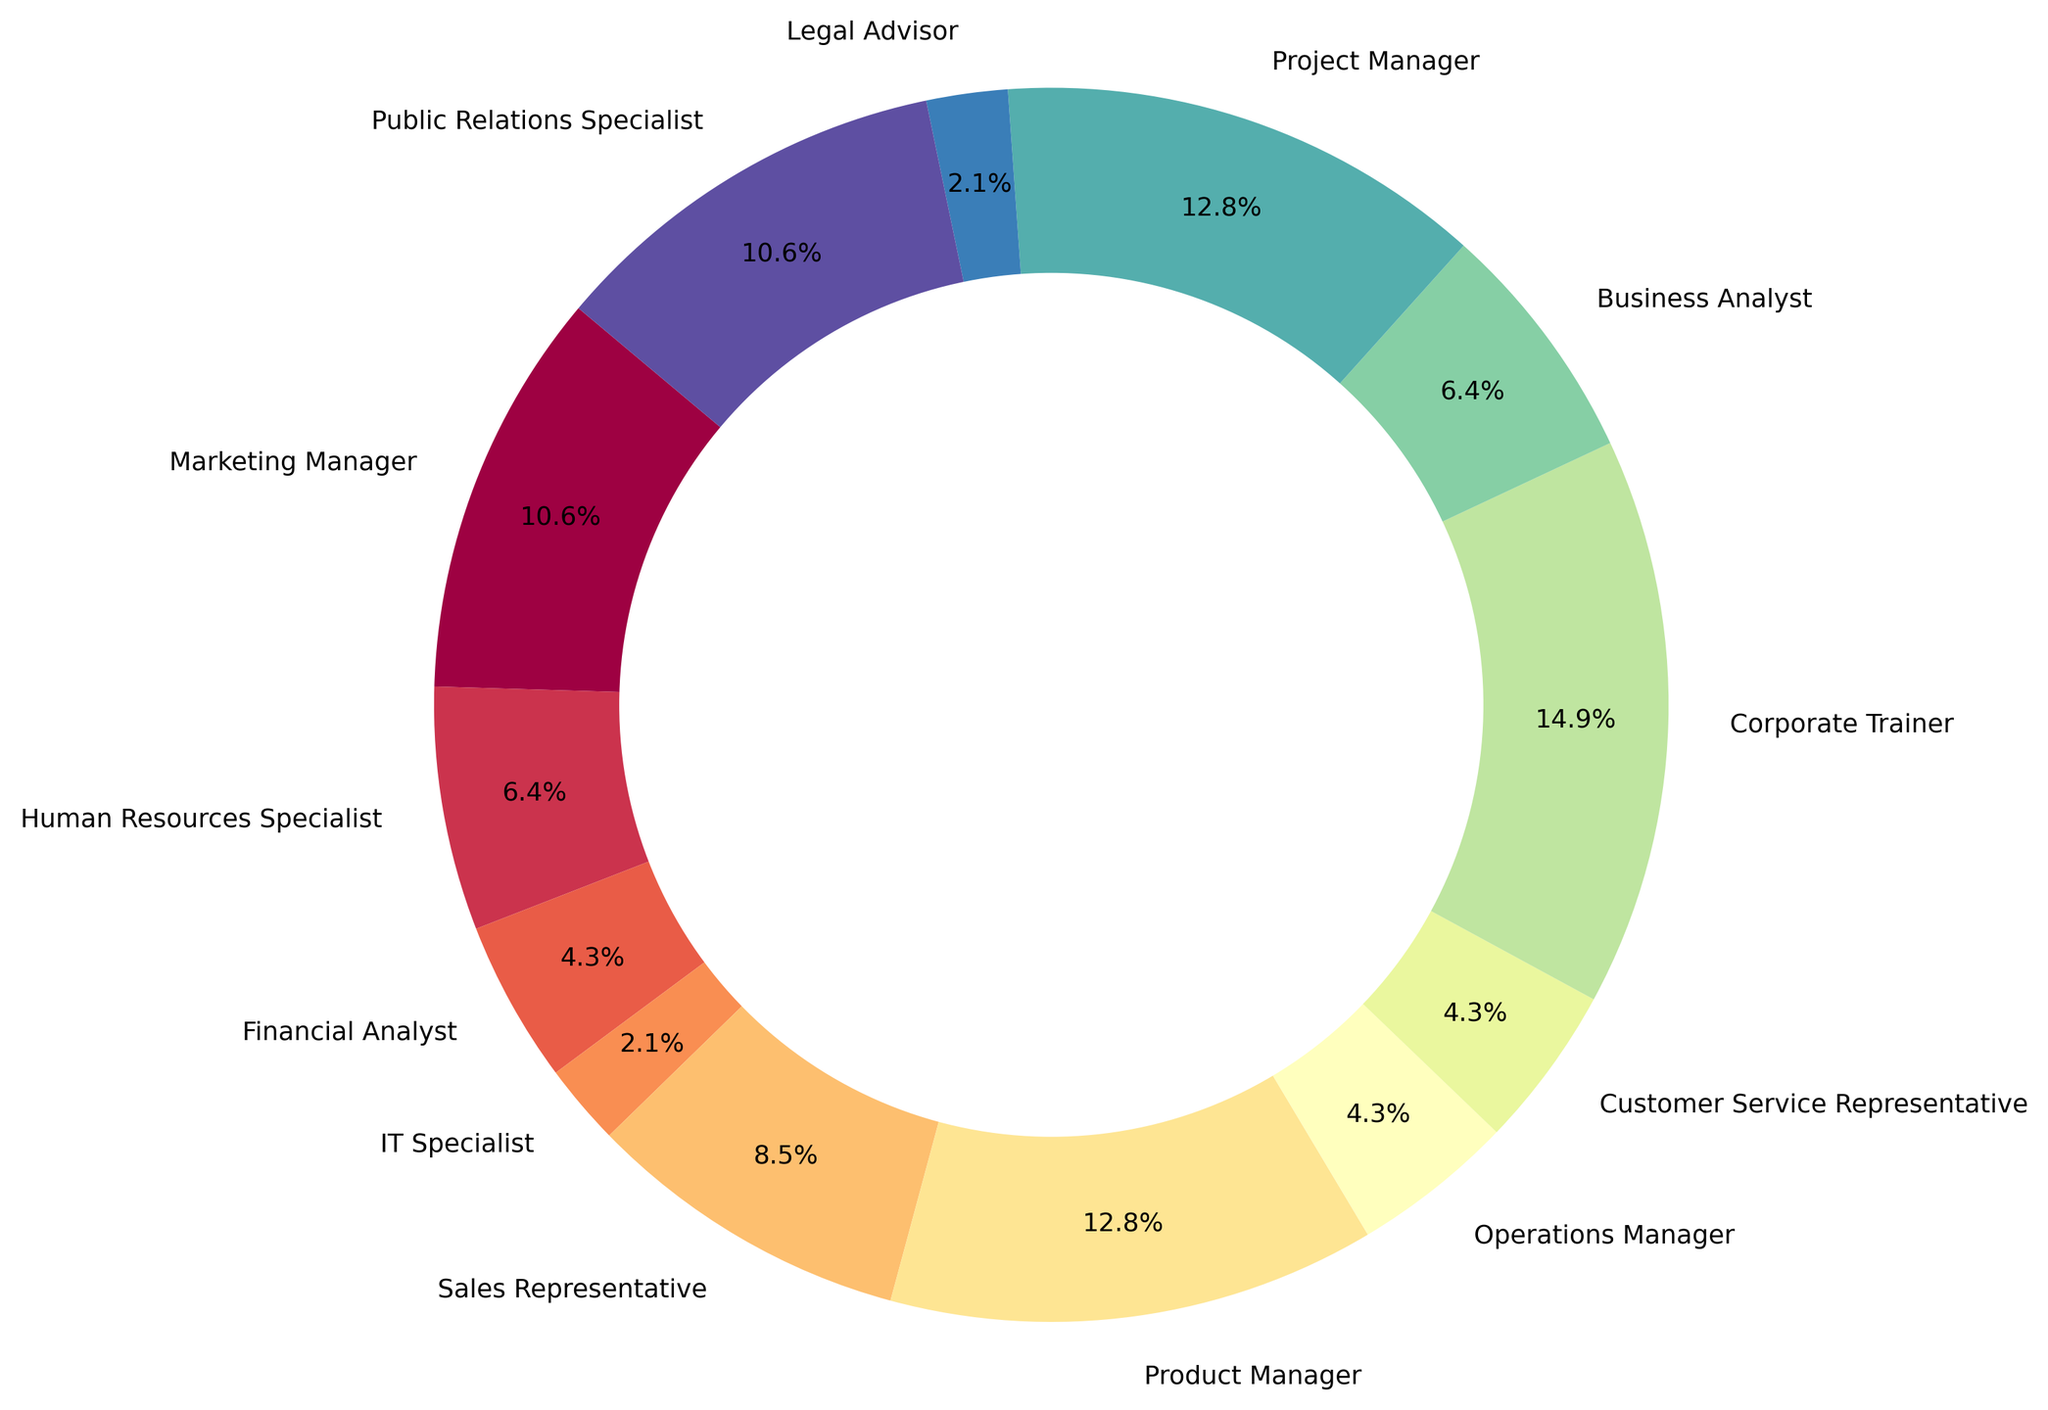What role utilizes the highest percentage of jazz knowledge? To determine the role that utilizes the highest percentage of jazz knowledge, look for the largest sector in the pie chart, which represents the Corporate Trainer role with a utilization percentage of 7%.
Answer: Corporate Trainer Which roles utilize exactly 6% of jazz knowledge? Identify the sectors that indicate 6% utilization on the pie chart. The roles given are Product Manager and Project Manager, both showing 6%.
Answer: Product Manager, Project Manager What's the combined jazz knowledge utilization percentage of roles in management positions (Marketing Manager, Product Manager, Operations Manager, and Project Manager)? To find the combined percentage, add the values for these roles: Marketing Manager (5%), Product Manager (6%), Operations Manager (2%), and Project Manager (6%). Total = 5% + 6% + 2% + 6% = 19%.
Answer: 19% How does the jazz knowledge utilization for a Sales Representative compare to that of a Human Resources Specialist? Compare the percentages for these roles from the pie chart. Sales Representatives utilize 4%, while Human Resources Specialists utilize 3%. Thus, Sales Representatives utilize 1% more jazz knowledge than Human Resources Specialists.
Answer: Sales Representatives utilize 1% more Which roles utilize the least percentage of jazz knowledge and what is the percentage? Look for the smallest sectors in the pie chart. Both IT Specialist and Legal Advisor utilize the least jazz knowledge at 1%.
Answer: IT Specialist and Legal Advisor, 1% What is the average percentage of jazz knowledge utilization across all roles? To compute the average, sum up all the percentages and divide by the number of roles. Sum of percentages = 5 + 3 + 2 + 1 + 4 + 6 + 2 + 2 + 7 + 3 + 6 + 1 + 5 = 47. Number of roles = 13. Average = 47 / 13 ≈ 3.62%.
Answer: 3.62% Between Public Relations Specialist and Marketing Manager, which role utilizes a higher percentage of jazz knowledge? Check the percentages for these roles on the pie chart. Public Relations Specialist and Marketing Manager both utilize 5% each. Since they are equal, neither role utilizes a higher percentage of jazz knowledge than the other.
Answer: Both utilize 5% What's the combined jazz knowledge utilization percentage of IT Specialist and Legal Advisor? Sum the percentages for these roles: IT Specialist (1%) and Legal Advisor (1%). Total = 1% + 1% = 2%.
Answer: 2% How does the jazz knowledge utilization of a Financial Analyst compare with that of an Operations Manager? Compare the percentages from the pie chart: Financial Analyst (2%) and Operations Manager (2%). They both utilize an equal percentage of jazz knowledge.
Answer: They are equal 